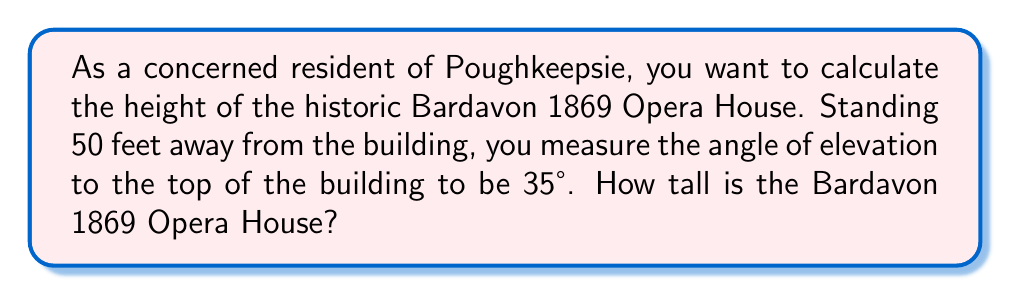Can you solve this math problem? Let's approach this step-by-step using trigonometry:

1) First, let's visualize the problem:

[asy]
import geometry;

size(200);
pair A = (0,0), B = (5,0), C = (5,3.5);
draw(A--B--C--A);
label("50 ft", (2.5,0), S);
label("Height", (5,1.75), E);
label("35°", A, SW);
dot("A", A, SW);
dot("B", B, SE);
dot("C", C, NE);
[/asy]

2) We have a right triangle where:
   - The adjacent side is the distance from you to the building (50 feet)
   - The opposite side is the height of the building (what we're solving for)
   - The angle of elevation is 35°

3) In this scenario, we can use the tangent function. Recall that:

   $$\tan(\theta) = \frac{\text{opposite}}{\text{adjacent}}$$

4) Let's plug in our known values:

   $$\tan(35°) = \frac{\text{height}}{50}$$

5) To solve for the height, we multiply both sides by 50:

   $$50 \cdot \tan(35°) = \text{height}$$

6) Now, let's calculate:
   
   $$\text{height} = 50 \cdot \tan(35°) \approx 50 \cdot 0.7002 \approx 35.01 \text{ feet}$$

7) Rounding to the nearest foot, the height of the Bardavon 1869 Opera House is approximately 35 feet.
Answer: 35 feet 